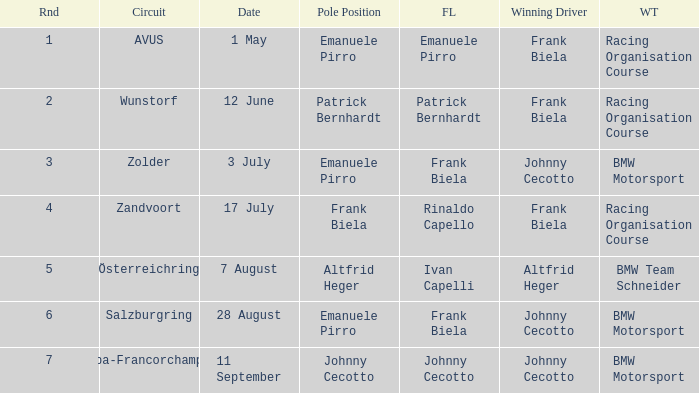Who had pole position in round 7? Johnny Cecotto. 